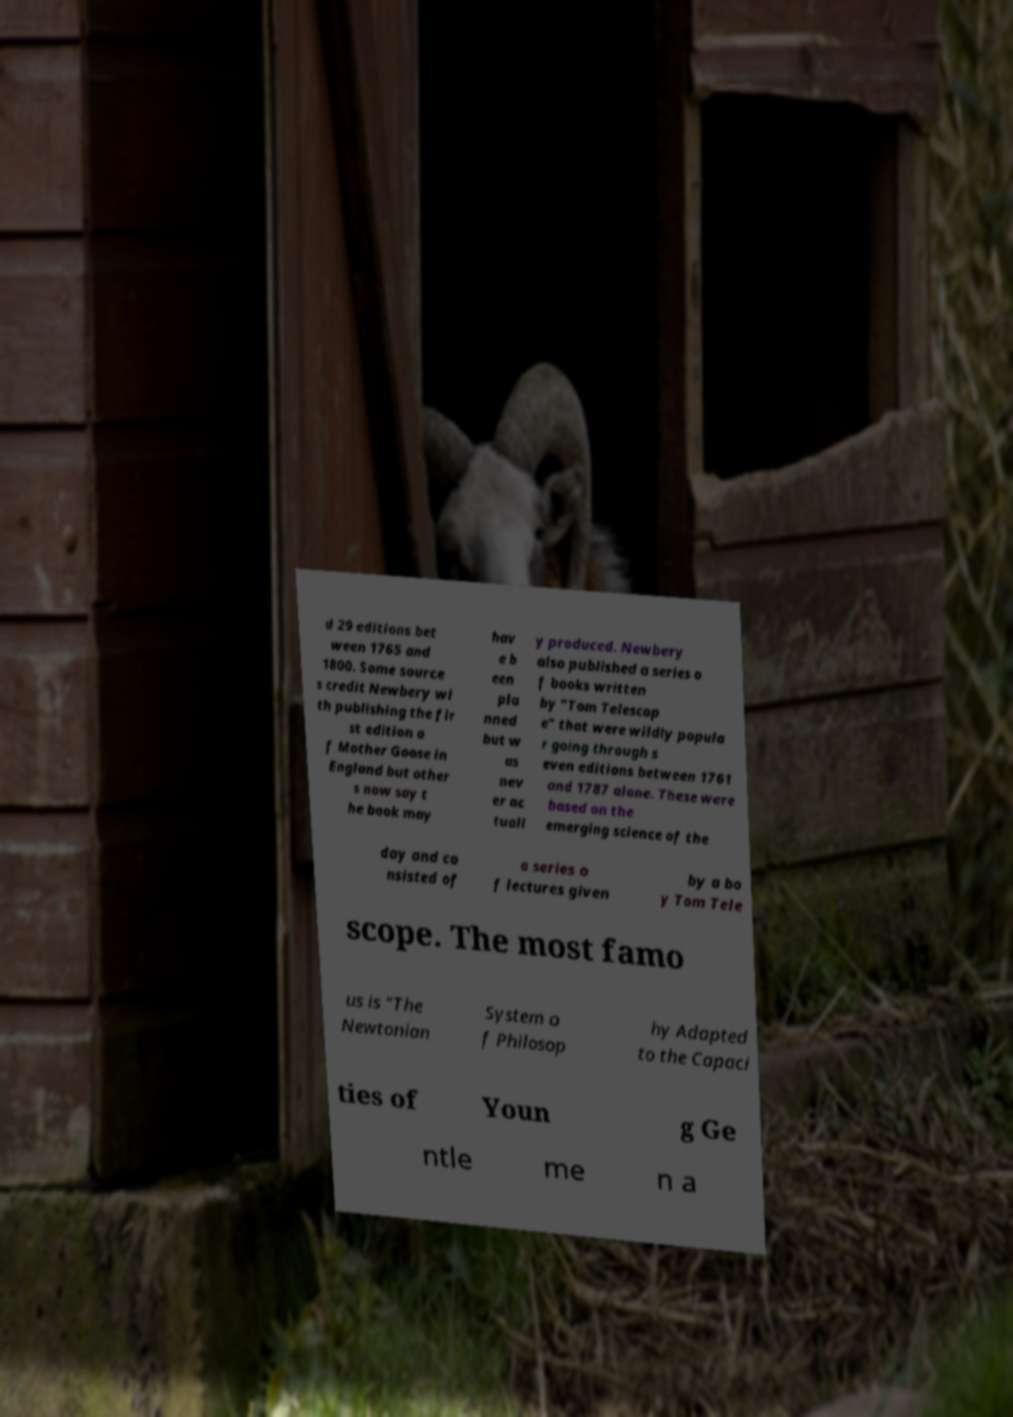I need the written content from this picture converted into text. Can you do that? d 29 editions bet ween 1765 and 1800. Some source s credit Newbery wi th publishing the fir st edition o f Mother Goose in England but other s now say t he book may hav e b een pla nned but w as nev er ac tuall y produced. Newbery also published a series o f books written by "Tom Telescop e" that were wildly popula r going through s even editions between 1761 and 1787 alone. These were based on the emerging science of the day and co nsisted of a series o f lectures given by a bo y Tom Tele scope. The most famo us is "The Newtonian System o f Philosop hy Adapted to the Capaci ties of Youn g Ge ntle me n a 